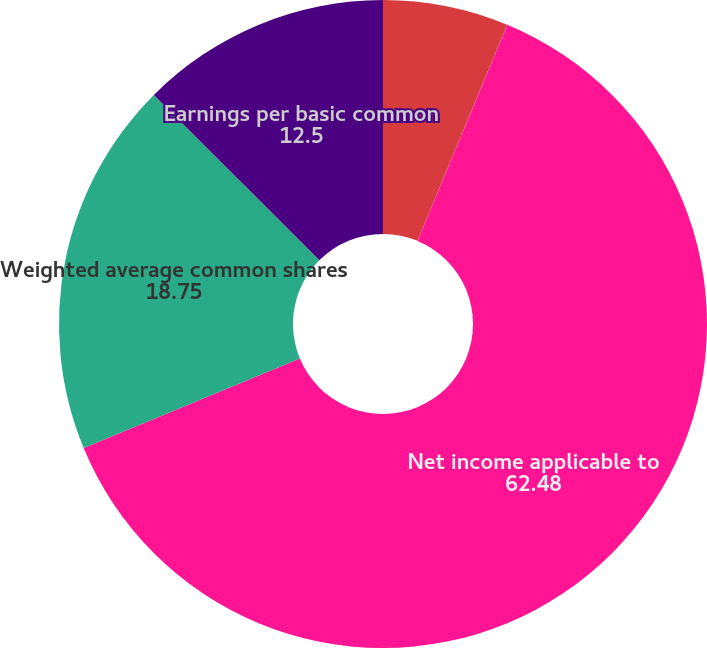Convert chart. <chart><loc_0><loc_0><loc_500><loc_500><pie_chart><fcel>Income from continuing<fcel>Gain on discontinued<fcel>Net income applicable to<fcel>Weighted average common shares<fcel>Earnings per basic common<nl><fcel>6.26%<fcel>0.01%<fcel>62.48%<fcel>18.75%<fcel>12.5%<nl></chart> 